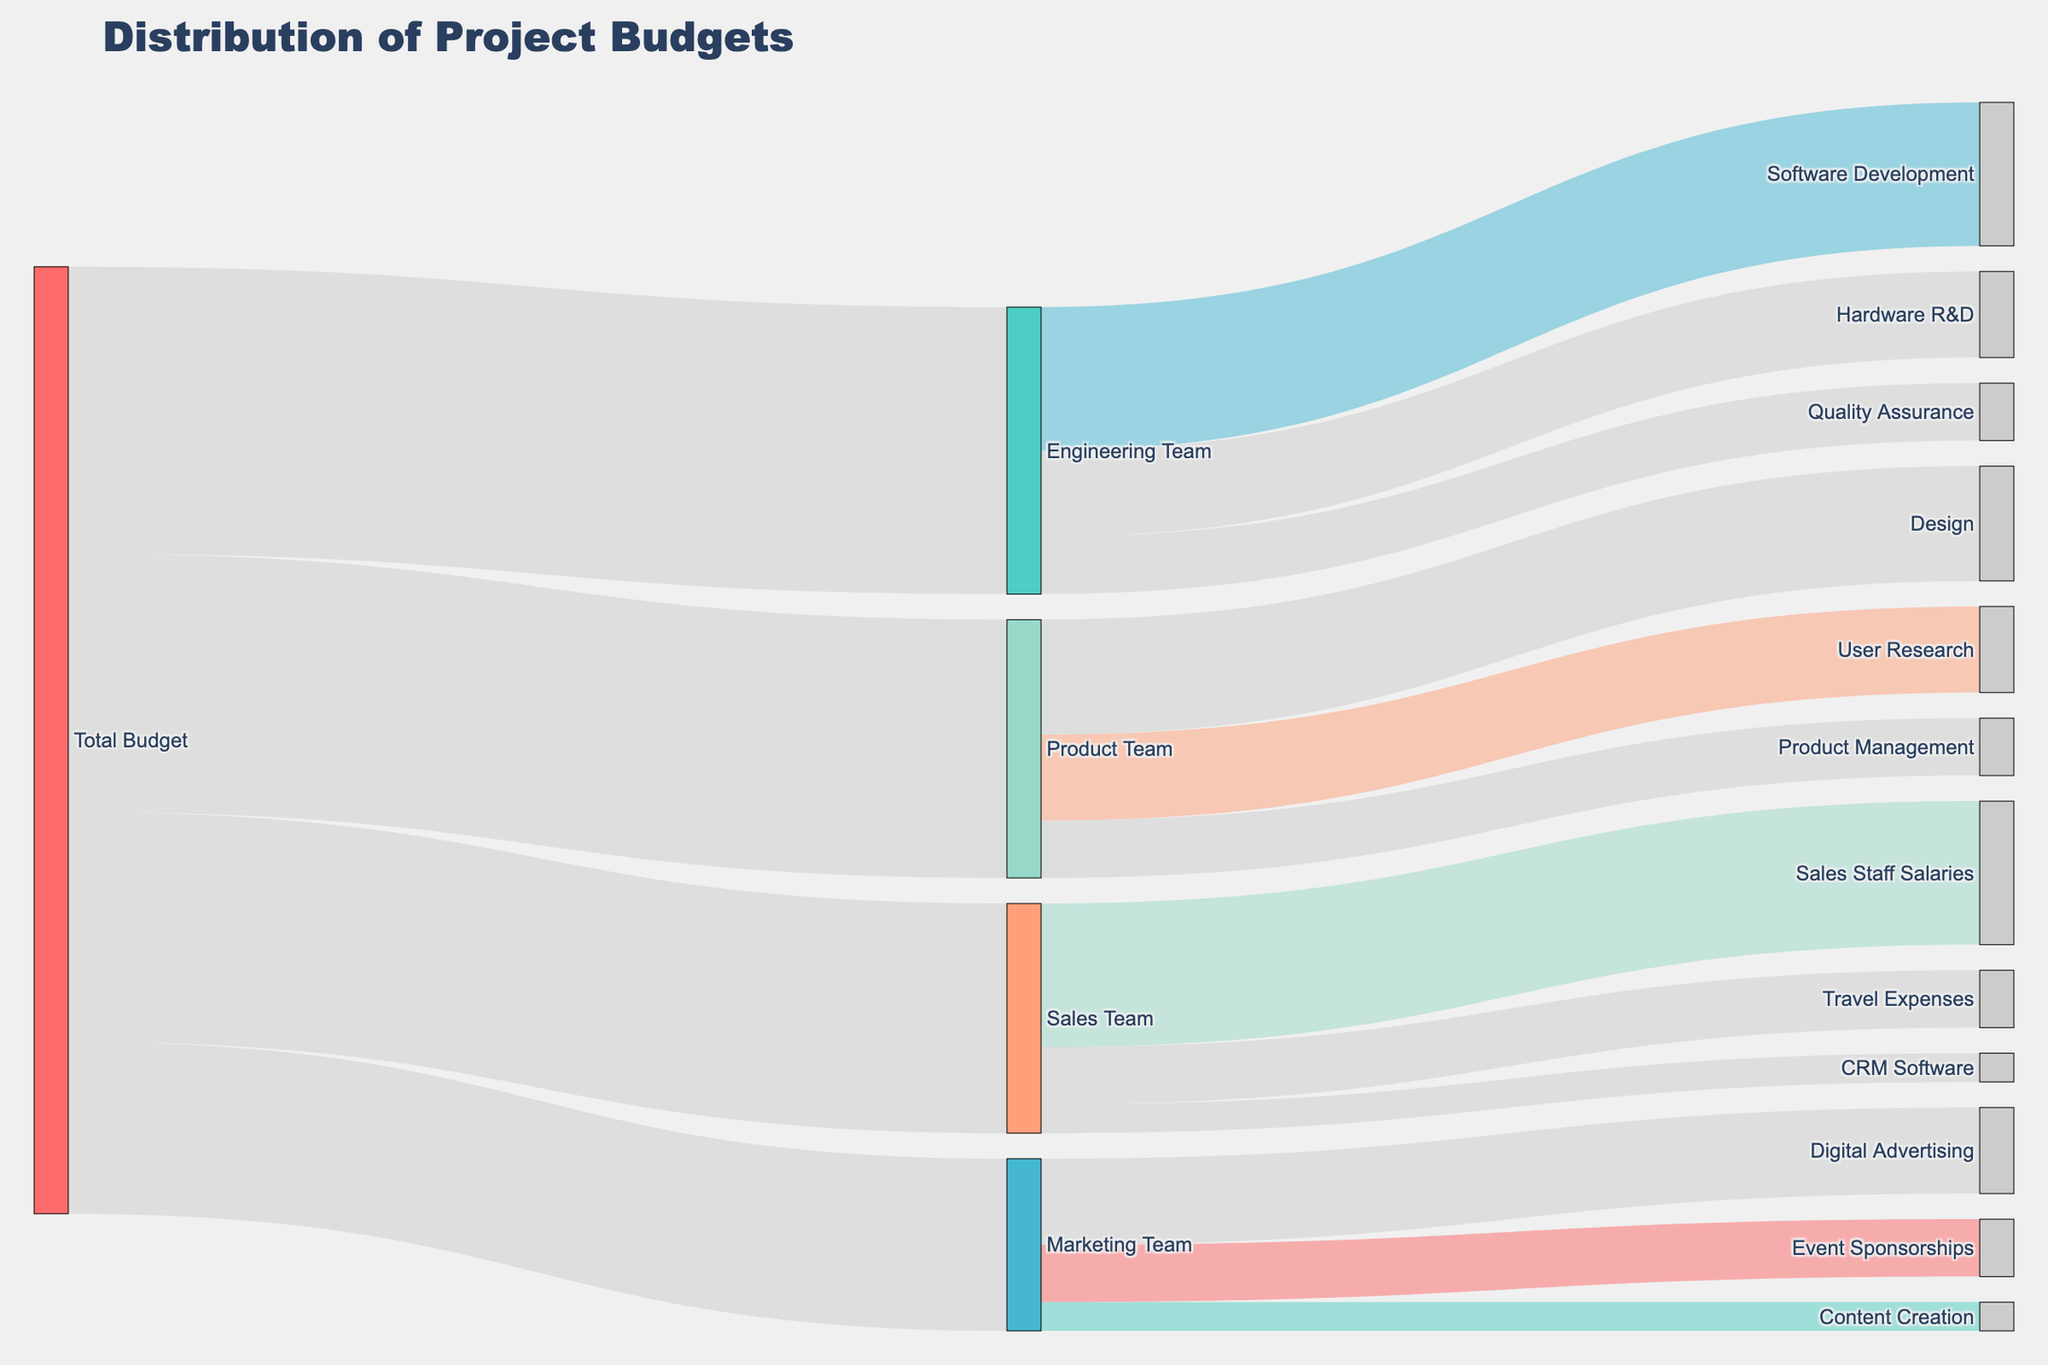Which team has the highest budget allocation? By examining the thickness of the lines coming from "Total Budget," we see that the Product Team has the highest allocation.
Answer: Product Team What is the total budget allocated to the Marketing Team? The line from "Total Budget" to "Marketing Team" shows a value of 300,000.
Answer: 300,000 How much is allocated to Software Development within the Engineering Team? By following the line from "Engineering Team" to "Software Development," we find the amount is 250,000.
Answer: 250,000 Which expense category in the Sales Team has the lowest allocation? From the branches of the Sales Team, "CRM Software" has the lowest value at 50,000.
Answer: CRM Software How much more budget is allocated to the Engineering Team compared to the Marketing Team? The budget for Engineering Team is 500,000 and for Marketing Team is 300,000. The difference is 500,000 - 300,000 = 200,000.
Answer: 200,000 What is the combined budget for User Research, Design, and Product Management in the Product Team? Summing the values for User Research (150,000), Design (200,000), and Product Management (100,000) gives 150,000 + 200,000 + 100,000 = 450,000.
Answer: 450,000 Which team has the least budget allocation? By comparing the values from "Total Budget" to each team, the Marketing Team has the least allocation at 300,000.
Answer: Marketing Team What percentage of the total budget is allocated to the Sales Team? The total budget is the sum of all allocations, i.e., 500,000 + 300,000 + 400,000 + 450,000 = 1,650,000. The percentage for Sales Team is (400,000 / 1,650,000) * 100 ≈ 24.24%.
Answer: Approximately 24.24% Is the budget allocation for Digital Advertising in the Marketing Team greater than the allocation for Quality Assurance in the Engineering Team? The budget for Digital Advertising is 150,000, and for Quality Assurance, it is 100,000. Since 150,000 > 100,000, Digital Advertising has a greater allocation.
Answer: Yes Which category within the Product Team receives the highest budget allocation? By looking at the lines branching from the Product Team, "Design" has the highest allocation at 200,000.
Answer: Design 